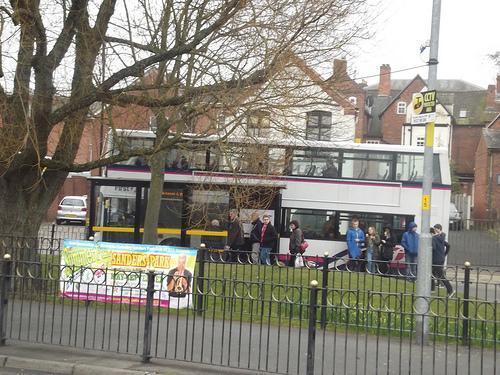How many people are on the banner?
Give a very brief answer. 1. How many signs are in front of the people?
Give a very brief answer. 2. 